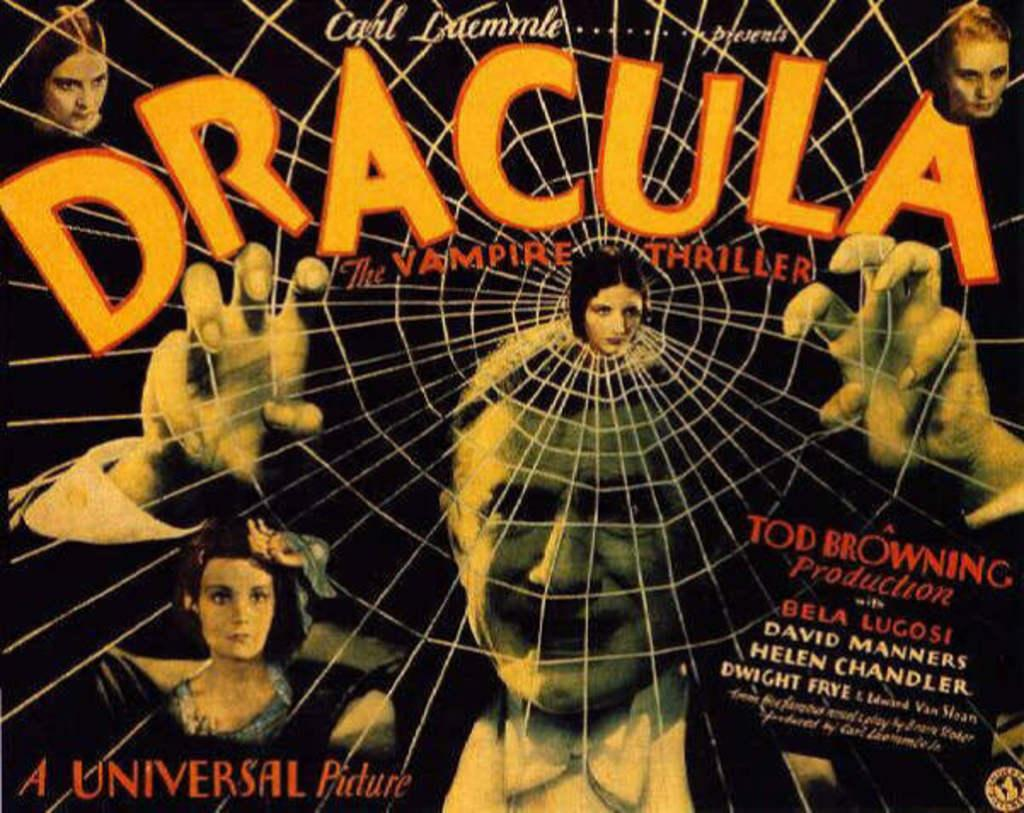<image>
Summarize the visual content of the image. A poster of the tod browning production of dracual 